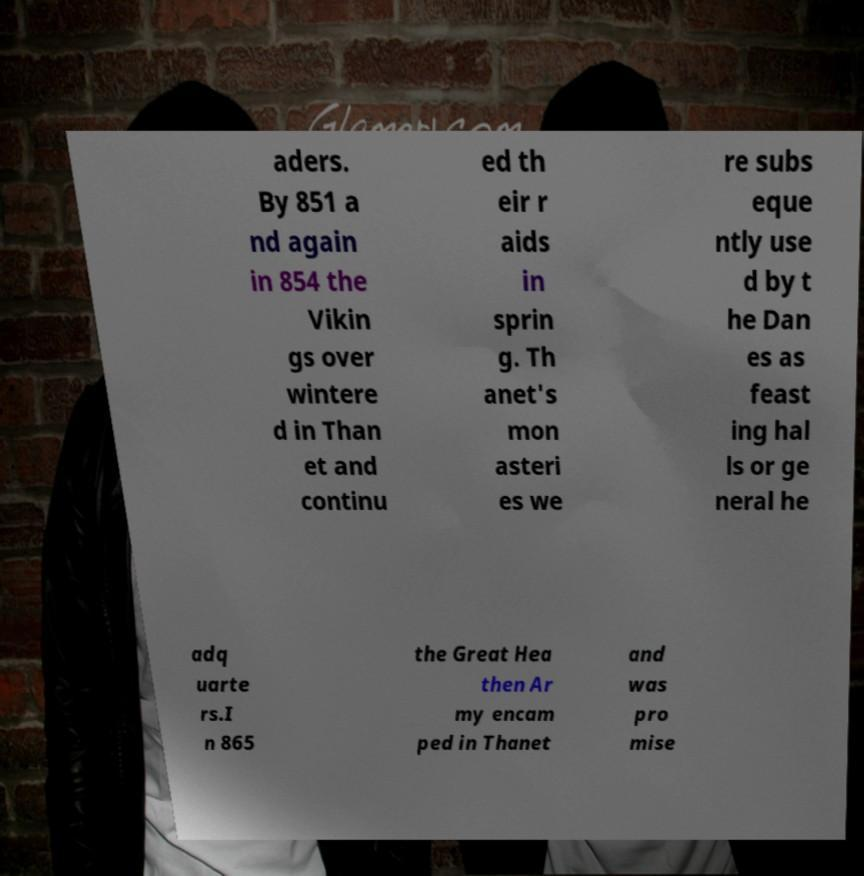Could you extract and type out the text from this image? aders. By 851 a nd again in 854 the Vikin gs over wintere d in Than et and continu ed th eir r aids in sprin g. Th anet's mon asteri es we re subs eque ntly use d by t he Dan es as feast ing hal ls or ge neral he adq uarte rs.I n 865 the Great Hea then Ar my encam ped in Thanet and was pro mise 